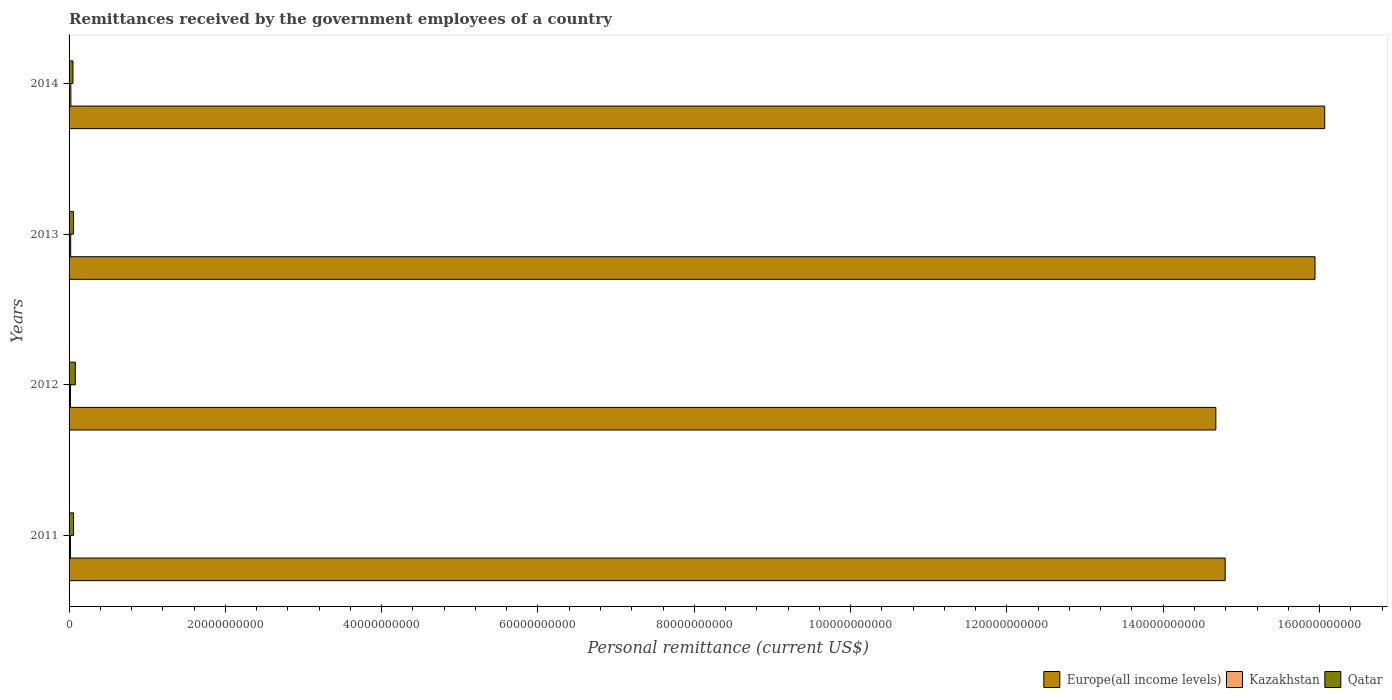How many different coloured bars are there?
Provide a succinct answer. 3. Are the number of bars per tick equal to the number of legend labels?
Your response must be concise. Yes. Are the number of bars on each tick of the Y-axis equal?
Offer a terse response. Yes. How many bars are there on the 3rd tick from the top?
Offer a very short reply. 3. How many bars are there on the 2nd tick from the bottom?
Your response must be concise. 3. What is the remittances received by the government employees in Europe(all income levels) in 2012?
Your response must be concise. 1.47e+11. Across all years, what is the maximum remittances received by the government employees in Qatar?
Make the answer very short. 8.03e+08. Across all years, what is the minimum remittances received by the government employees in Qatar?
Give a very brief answer. 4.99e+08. In which year was the remittances received by the government employees in Europe(all income levels) maximum?
Ensure brevity in your answer.  2014. What is the total remittances received by the government employees in Qatar in the graph?
Ensure brevity in your answer.  2.45e+09. What is the difference between the remittances received by the government employees in Qatar in 2012 and that in 2013?
Offer a very short reply. 2.29e+08. What is the difference between the remittances received by the government employees in Qatar in 2011 and the remittances received by the government employees in Europe(all income levels) in 2014?
Your answer should be very brief. -1.60e+11. What is the average remittances received by the government employees in Kazakhstan per year?
Your response must be concise. 1.98e+08. In the year 2014, what is the difference between the remittances received by the government employees in Qatar and remittances received by the government employees in Kazakhstan?
Your answer should be very brief. 2.70e+08. What is the ratio of the remittances received by the government employees in Kazakhstan in 2013 to that in 2014?
Make the answer very short. 0.91. Is the remittances received by the government employees in Qatar in 2012 less than that in 2014?
Ensure brevity in your answer.  No. Is the difference between the remittances received by the government employees in Qatar in 2011 and 2013 greater than the difference between the remittances received by the government employees in Kazakhstan in 2011 and 2013?
Your response must be concise. Yes. What is the difference between the highest and the second highest remittances received by the government employees in Europe(all income levels)?
Offer a very short reply. 1.24e+09. What is the difference between the highest and the lowest remittances received by the government employees in Kazakhstan?
Your answer should be very brief. 5.04e+07. In how many years, is the remittances received by the government employees in Kazakhstan greater than the average remittances received by the government employees in Kazakhstan taken over all years?
Provide a short and direct response. 2. What does the 2nd bar from the top in 2013 represents?
Offer a very short reply. Kazakhstan. What does the 2nd bar from the bottom in 2014 represents?
Your answer should be very brief. Kazakhstan. Is it the case that in every year, the sum of the remittances received by the government employees in Kazakhstan and remittances received by the government employees in Europe(all income levels) is greater than the remittances received by the government employees in Qatar?
Ensure brevity in your answer.  Yes. How many bars are there?
Give a very brief answer. 12. What is the difference between two consecutive major ticks on the X-axis?
Offer a terse response. 2.00e+1. Are the values on the major ticks of X-axis written in scientific E-notation?
Provide a succinct answer. No. How are the legend labels stacked?
Your response must be concise. Horizontal. What is the title of the graph?
Make the answer very short. Remittances received by the government employees of a country. Does "Timor-Leste" appear as one of the legend labels in the graph?
Ensure brevity in your answer.  No. What is the label or title of the X-axis?
Your answer should be very brief. Personal remittance (current US$). What is the Personal remittance (current US$) of Europe(all income levels) in 2011?
Give a very brief answer. 1.48e+11. What is the Personal remittance (current US$) of Kazakhstan in 2011?
Your answer should be compact. 1.80e+08. What is the Personal remittance (current US$) of Qatar in 2011?
Keep it short and to the point. 5.74e+08. What is the Personal remittance (current US$) of Europe(all income levels) in 2012?
Provide a succinct answer. 1.47e+11. What is the Personal remittance (current US$) of Kazakhstan in 2012?
Give a very brief answer. 1.78e+08. What is the Personal remittance (current US$) in Qatar in 2012?
Offer a very short reply. 8.03e+08. What is the Personal remittance (current US$) in Europe(all income levels) in 2013?
Give a very brief answer. 1.59e+11. What is the Personal remittance (current US$) of Kazakhstan in 2013?
Keep it short and to the point. 2.07e+08. What is the Personal remittance (current US$) in Qatar in 2013?
Ensure brevity in your answer.  5.74e+08. What is the Personal remittance (current US$) of Europe(all income levels) in 2014?
Your answer should be compact. 1.61e+11. What is the Personal remittance (current US$) of Kazakhstan in 2014?
Give a very brief answer. 2.29e+08. What is the Personal remittance (current US$) of Qatar in 2014?
Your response must be concise. 4.99e+08. Across all years, what is the maximum Personal remittance (current US$) in Europe(all income levels)?
Give a very brief answer. 1.61e+11. Across all years, what is the maximum Personal remittance (current US$) in Kazakhstan?
Provide a short and direct response. 2.29e+08. Across all years, what is the maximum Personal remittance (current US$) in Qatar?
Ensure brevity in your answer.  8.03e+08. Across all years, what is the minimum Personal remittance (current US$) in Europe(all income levels)?
Provide a short and direct response. 1.47e+11. Across all years, what is the minimum Personal remittance (current US$) in Kazakhstan?
Give a very brief answer. 1.78e+08. Across all years, what is the minimum Personal remittance (current US$) of Qatar?
Provide a succinct answer. 4.99e+08. What is the total Personal remittance (current US$) of Europe(all income levels) in the graph?
Provide a succinct answer. 6.15e+11. What is the total Personal remittance (current US$) in Kazakhstan in the graph?
Keep it short and to the point. 7.93e+08. What is the total Personal remittance (current US$) of Qatar in the graph?
Your answer should be compact. 2.45e+09. What is the difference between the Personal remittance (current US$) in Europe(all income levels) in 2011 and that in 2012?
Your response must be concise. 1.19e+09. What is the difference between the Personal remittance (current US$) of Kazakhstan in 2011 and that in 2012?
Give a very brief answer. 1.57e+06. What is the difference between the Personal remittance (current US$) in Qatar in 2011 and that in 2012?
Your answer should be compact. -2.30e+08. What is the difference between the Personal remittance (current US$) in Europe(all income levels) in 2011 and that in 2013?
Ensure brevity in your answer.  -1.15e+1. What is the difference between the Personal remittance (current US$) of Kazakhstan in 2011 and that in 2013?
Offer a very short reply. -2.73e+07. What is the difference between the Personal remittance (current US$) of Qatar in 2011 and that in 2013?
Your response must be concise. -7.69e+05. What is the difference between the Personal remittance (current US$) of Europe(all income levels) in 2011 and that in 2014?
Your response must be concise. -1.27e+1. What is the difference between the Personal remittance (current US$) in Kazakhstan in 2011 and that in 2014?
Provide a short and direct response. -4.88e+07. What is the difference between the Personal remittance (current US$) in Qatar in 2011 and that in 2014?
Ensure brevity in your answer.  7.50e+07. What is the difference between the Personal remittance (current US$) in Europe(all income levels) in 2012 and that in 2013?
Offer a very short reply. -1.27e+1. What is the difference between the Personal remittance (current US$) in Kazakhstan in 2012 and that in 2013?
Keep it short and to the point. -2.88e+07. What is the difference between the Personal remittance (current US$) in Qatar in 2012 and that in 2013?
Your answer should be compact. 2.29e+08. What is the difference between the Personal remittance (current US$) in Europe(all income levels) in 2012 and that in 2014?
Your answer should be very brief. -1.39e+1. What is the difference between the Personal remittance (current US$) in Kazakhstan in 2012 and that in 2014?
Ensure brevity in your answer.  -5.04e+07. What is the difference between the Personal remittance (current US$) in Qatar in 2012 and that in 2014?
Your answer should be compact. 3.05e+08. What is the difference between the Personal remittance (current US$) in Europe(all income levels) in 2013 and that in 2014?
Provide a short and direct response. -1.24e+09. What is the difference between the Personal remittance (current US$) in Kazakhstan in 2013 and that in 2014?
Provide a short and direct response. -2.16e+07. What is the difference between the Personal remittance (current US$) in Qatar in 2013 and that in 2014?
Your response must be concise. 7.58e+07. What is the difference between the Personal remittance (current US$) of Europe(all income levels) in 2011 and the Personal remittance (current US$) of Kazakhstan in 2012?
Keep it short and to the point. 1.48e+11. What is the difference between the Personal remittance (current US$) in Europe(all income levels) in 2011 and the Personal remittance (current US$) in Qatar in 2012?
Your answer should be compact. 1.47e+11. What is the difference between the Personal remittance (current US$) in Kazakhstan in 2011 and the Personal remittance (current US$) in Qatar in 2012?
Your answer should be compact. -6.24e+08. What is the difference between the Personal remittance (current US$) in Europe(all income levels) in 2011 and the Personal remittance (current US$) in Kazakhstan in 2013?
Ensure brevity in your answer.  1.48e+11. What is the difference between the Personal remittance (current US$) in Europe(all income levels) in 2011 and the Personal remittance (current US$) in Qatar in 2013?
Provide a short and direct response. 1.47e+11. What is the difference between the Personal remittance (current US$) of Kazakhstan in 2011 and the Personal remittance (current US$) of Qatar in 2013?
Your answer should be compact. -3.95e+08. What is the difference between the Personal remittance (current US$) of Europe(all income levels) in 2011 and the Personal remittance (current US$) of Kazakhstan in 2014?
Give a very brief answer. 1.48e+11. What is the difference between the Personal remittance (current US$) in Europe(all income levels) in 2011 and the Personal remittance (current US$) in Qatar in 2014?
Make the answer very short. 1.47e+11. What is the difference between the Personal remittance (current US$) of Kazakhstan in 2011 and the Personal remittance (current US$) of Qatar in 2014?
Your answer should be very brief. -3.19e+08. What is the difference between the Personal remittance (current US$) of Europe(all income levels) in 2012 and the Personal remittance (current US$) of Kazakhstan in 2013?
Offer a terse response. 1.47e+11. What is the difference between the Personal remittance (current US$) in Europe(all income levels) in 2012 and the Personal remittance (current US$) in Qatar in 2013?
Provide a succinct answer. 1.46e+11. What is the difference between the Personal remittance (current US$) in Kazakhstan in 2012 and the Personal remittance (current US$) in Qatar in 2013?
Offer a terse response. -3.96e+08. What is the difference between the Personal remittance (current US$) in Europe(all income levels) in 2012 and the Personal remittance (current US$) in Kazakhstan in 2014?
Your answer should be very brief. 1.47e+11. What is the difference between the Personal remittance (current US$) in Europe(all income levels) in 2012 and the Personal remittance (current US$) in Qatar in 2014?
Make the answer very short. 1.46e+11. What is the difference between the Personal remittance (current US$) of Kazakhstan in 2012 and the Personal remittance (current US$) of Qatar in 2014?
Ensure brevity in your answer.  -3.20e+08. What is the difference between the Personal remittance (current US$) of Europe(all income levels) in 2013 and the Personal remittance (current US$) of Kazakhstan in 2014?
Provide a succinct answer. 1.59e+11. What is the difference between the Personal remittance (current US$) of Europe(all income levels) in 2013 and the Personal remittance (current US$) of Qatar in 2014?
Your answer should be very brief. 1.59e+11. What is the difference between the Personal remittance (current US$) of Kazakhstan in 2013 and the Personal remittance (current US$) of Qatar in 2014?
Your answer should be compact. -2.92e+08. What is the average Personal remittance (current US$) of Europe(all income levels) per year?
Provide a short and direct response. 1.54e+11. What is the average Personal remittance (current US$) of Kazakhstan per year?
Offer a terse response. 1.98e+08. What is the average Personal remittance (current US$) of Qatar per year?
Your response must be concise. 6.12e+08. In the year 2011, what is the difference between the Personal remittance (current US$) in Europe(all income levels) and Personal remittance (current US$) in Kazakhstan?
Keep it short and to the point. 1.48e+11. In the year 2011, what is the difference between the Personal remittance (current US$) in Europe(all income levels) and Personal remittance (current US$) in Qatar?
Ensure brevity in your answer.  1.47e+11. In the year 2011, what is the difference between the Personal remittance (current US$) of Kazakhstan and Personal remittance (current US$) of Qatar?
Ensure brevity in your answer.  -3.94e+08. In the year 2012, what is the difference between the Personal remittance (current US$) of Europe(all income levels) and Personal remittance (current US$) of Kazakhstan?
Keep it short and to the point. 1.47e+11. In the year 2012, what is the difference between the Personal remittance (current US$) of Europe(all income levels) and Personal remittance (current US$) of Qatar?
Ensure brevity in your answer.  1.46e+11. In the year 2012, what is the difference between the Personal remittance (current US$) in Kazakhstan and Personal remittance (current US$) in Qatar?
Offer a very short reply. -6.25e+08. In the year 2013, what is the difference between the Personal remittance (current US$) of Europe(all income levels) and Personal remittance (current US$) of Kazakhstan?
Offer a very short reply. 1.59e+11. In the year 2013, what is the difference between the Personal remittance (current US$) of Europe(all income levels) and Personal remittance (current US$) of Qatar?
Offer a very short reply. 1.59e+11. In the year 2013, what is the difference between the Personal remittance (current US$) of Kazakhstan and Personal remittance (current US$) of Qatar?
Your answer should be very brief. -3.67e+08. In the year 2014, what is the difference between the Personal remittance (current US$) in Europe(all income levels) and Personal remittance (current US$) in Kazakhstan?
Keep it short and to the point. 1.60e+11. In the year 2014, what is the difference between the Personal remittance (current US$) of Europe(all income levels) and Personal remittance (current US$) of Qatar?
Offer a very short reply. 1.60e+11. In the year 2014, what is the difference between the Personal remittance (current US$) of Kazakhstan and Personal remittance (current US$) of Qatar?
Provide a short and direct response. -2.70e+08. What is the ratio of the Personal remittance (current US$) in Europe(all income levels) in 2011 to that in 2012?
Your answer should be very brief. 1.01. What is the ratio of the Personal remittance (current US$) of Kazakhstan in 2011 to that in 2012?
Your response must be concise. 1.01. What is the ratio of the Personal remittance (current US$) of Qatar in 2011 to that in 2012?
Give a very brief answer. 0.71. What is the ratio of the Personal remittance (current US$) of Europe(all income levels) in 2011 to that in 2013?
Provide a short and direct response. 0.93. What is the ratio of the Personal remittance (current US$) in Kazakhstan in 2011 to that in 2013?
Make the answer very short. 0.87. What is the ratio of the Personal remittance (current US$) in Qatar in 2011 to that in 2013?
Offer a very short reply. 1. What is the ratio of the Personal remittance (current US$) of Europe(all income levels) in 2011 to that in 2014?
Offer a terse response. 0.92. What is the ratio of the Personal remittance (current US$) in Kazakhstan in 2011 to that in 2014?
Offer a terse response. 0.79. What is the ratio of the Personal remittance (current US$) in Qatar in 2011 to that in 2014?
Give a very brief answer. 1.15. What is the ratio of the Personal remittance (current US$) in Europe(all income levels) in 2012 to that in 2013?
Keep it short and to the point. 0.92. What is the ratio of the Personal remittance (current US$) in Kazakhstan in 2012 to that in 2013?
Keep it short and to the point. 0.86. What is the ratio of the Personal remittance (current US$) in Qatar in 2012 to that in 2013?
Provide a succinct answer. 1.4. What is the ratio of the Personal remittance (current US$) of Europe(all income levels) in 2012 to that in 2014?
Your answer should be compact. 0.91. What is the ratio of the Personal remittance (current US$) of Kazakhstan in 2012 to that in 2014?
Your answer should be compact. 0.78. What is the ratio of the Personal remittance (current US$) in Qatar in 2012 to that in 2014?
Offer a very short reply. 1.61. What is the ratio of the Personal remittance (current US$) of Kazakhstan in 2013 to that in 2014?
Ensure brevity in your answer.  0.91. What is the ratio of the Personal remittance (current US$) of Qatar in 2013 to that in 2014?
Offer a very short reply. 1.15. What is the difference between the highest and the second highest Personal remittance (current US$) of Europe(all income levels)?
Provide a short and direct response. 1.24e+09. What is the difference between the highest and the second highest Personal remittance (current US$) of Kazakhstan?
Provide a succinct answer. 2.16e+07. What is the difference between the highest and the second highest Personal remittance (current US$) in Qatar?
Provide a succinct answer. 2.29e+08. What is the difference between the highest and the lowest Personal remittance (current US$) in Europe(all income levels)?
Offer a terse response. 1.39e+1. What is the difference between the highest and the lowest Personal remittance (current US$) of Kazakhstan?
Offer a very short reply. 5.04e+07. What is the difference between the highest and the lowest Personal remittance (current US$) of Qatar?
Give a very brief answer. 3.05e+08. 